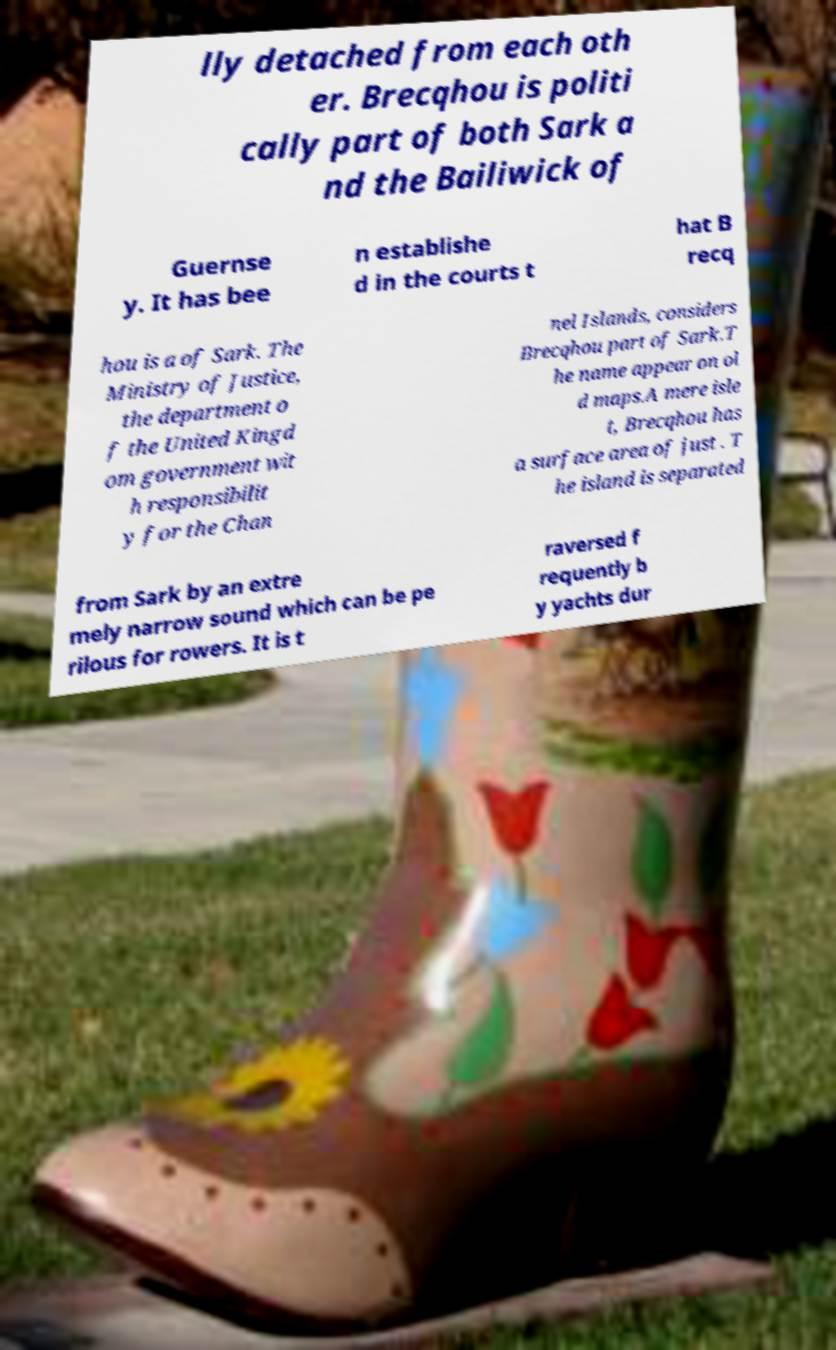For documentation purposes, I need the text within this image transcribed. Could you provide that? lly detached from each oth er. Brecqhou is politi cally part of both Sark a nd the Bailiwick of Guernse y. It has bee n establishe d in the courts t hat B recq hou is a of Sark. The Ministry of Justice, the department o f the United Kingd om government wit h responsibilit y for the Chan nel Islands, considers Brecqhou part of Sark.T he name appear on ol d maps.A mere isle t, Brecqhou has a surface area of just . T he island is separated from Sark by an extre mely narrow sound which can be pe rilous for rowers. It is t raversed f requently b y yachts dur 